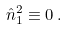<formula> <loc_0><loc_0><loc_500><loc_500>\hat { n } _ { 1 } ^ { 2 } \equiv 0 \, .</formula> 